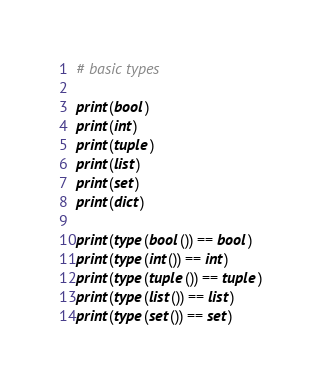Convert code to text. <code><loc_0><loc_0><loc_500><loc_500><_Python_># basic types

print(bool)
print(int)
print(tuple)
print(list)
print(set)
print(dict)

print(type(bool()) == bool)
print(type(int()) == int)
print(type(tuple()) == tuple)
print(type(list()) == list)
print(type(set()) == set)</code> 